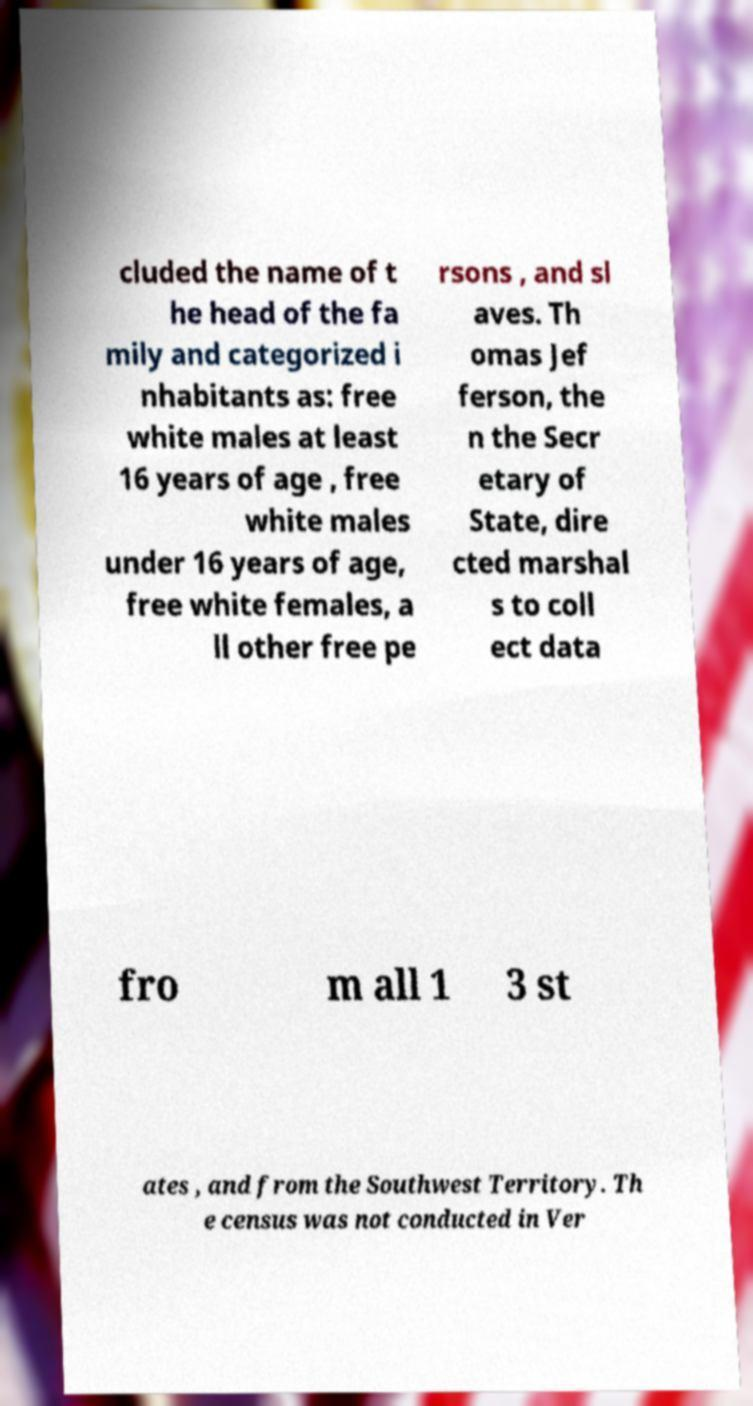What messages or text are displayed in this image? I need them in a readable, typed format. cluded the name of t he head of the fa mily and categorized i nhabitants as: free white males at least 16 years of age , free white males under 16 years of age, free white females, a ll other free pe rsons , and sl aves. Th omas Jef ferson, the n the Secr etary of State, dire cted marshal s to coll ect data fro m all 1 3 st ates , and from the Southwest Territory. Th e census was not conducted in Ver 